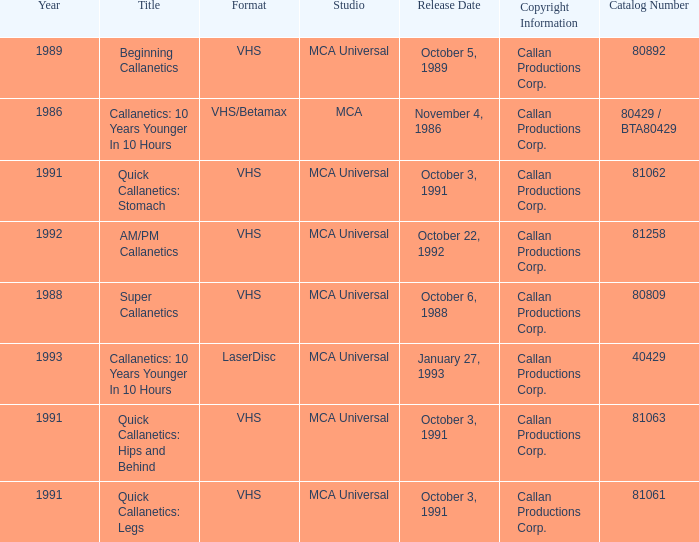Name the studio for catalog number 81063 MCA Universal. Can you parse all the data within this table? {'header': ['Year', 'Title', 'Format', 'Studio', 'Release Date', 'Copyright Information', 'Catalog Number'], 'rows': [['1989', 'Beginning Callanetics', 'VHS', 'MCA Universal', 'October 5, 1989', 'Callan Productions Corp.', '80892'], ['1986', 'Callanetics: 10 Years Younger In 10 Hours', 'VHS/Betamax', 'MCA', 'November 4, 1986', 'Callan Productions Corp.', '80429 / BTA80429'], ['1991', 'Quick Callanetics: Stomach', 'VHS', 'MCA Universal', 'October 3, 1991', 'Callan Productions Corp.', '81062'], ['1992', 'AM/PM Callanetics', 'VHS', 'MCA Universal', 'October 22, 1992', 'Callan Productions Corp.', '81258'], ['1988', 'Super Callanetics', 'VHS', 'MCA Universal', 'October 6, 1988', 'Callan Productions Corp.', '80809'], ['1993', 'Callanetics: 10 Years Younger In 10 Hours', 'LaserDisc', 'MCA Universal', 'January 27, 1993', 'Callan Productions Corp.', '40429'], ['1991', 'Quick Callanetics: Hips and Behind', 'VHS', 'MCA Universal', 'October 3, 1991', 'Callan Productions Corp.', '81063'], ['1991', 'Quick Callanetics: Legs', 'VHS', 'MCA Universal', 'October 3, 1991', 'Callan Productions Corp.', '81061']]} 